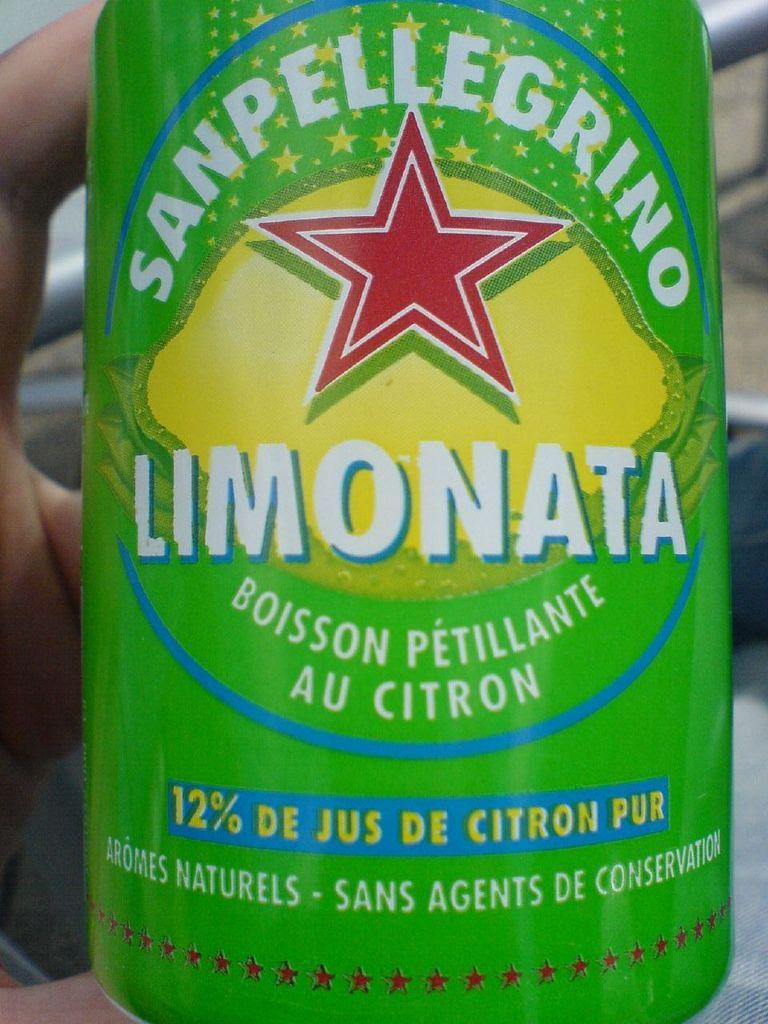<image>
Offer a succinct explanation of the picture presented. The can of Pellegrino Limonata says it contains 12% real juice. 